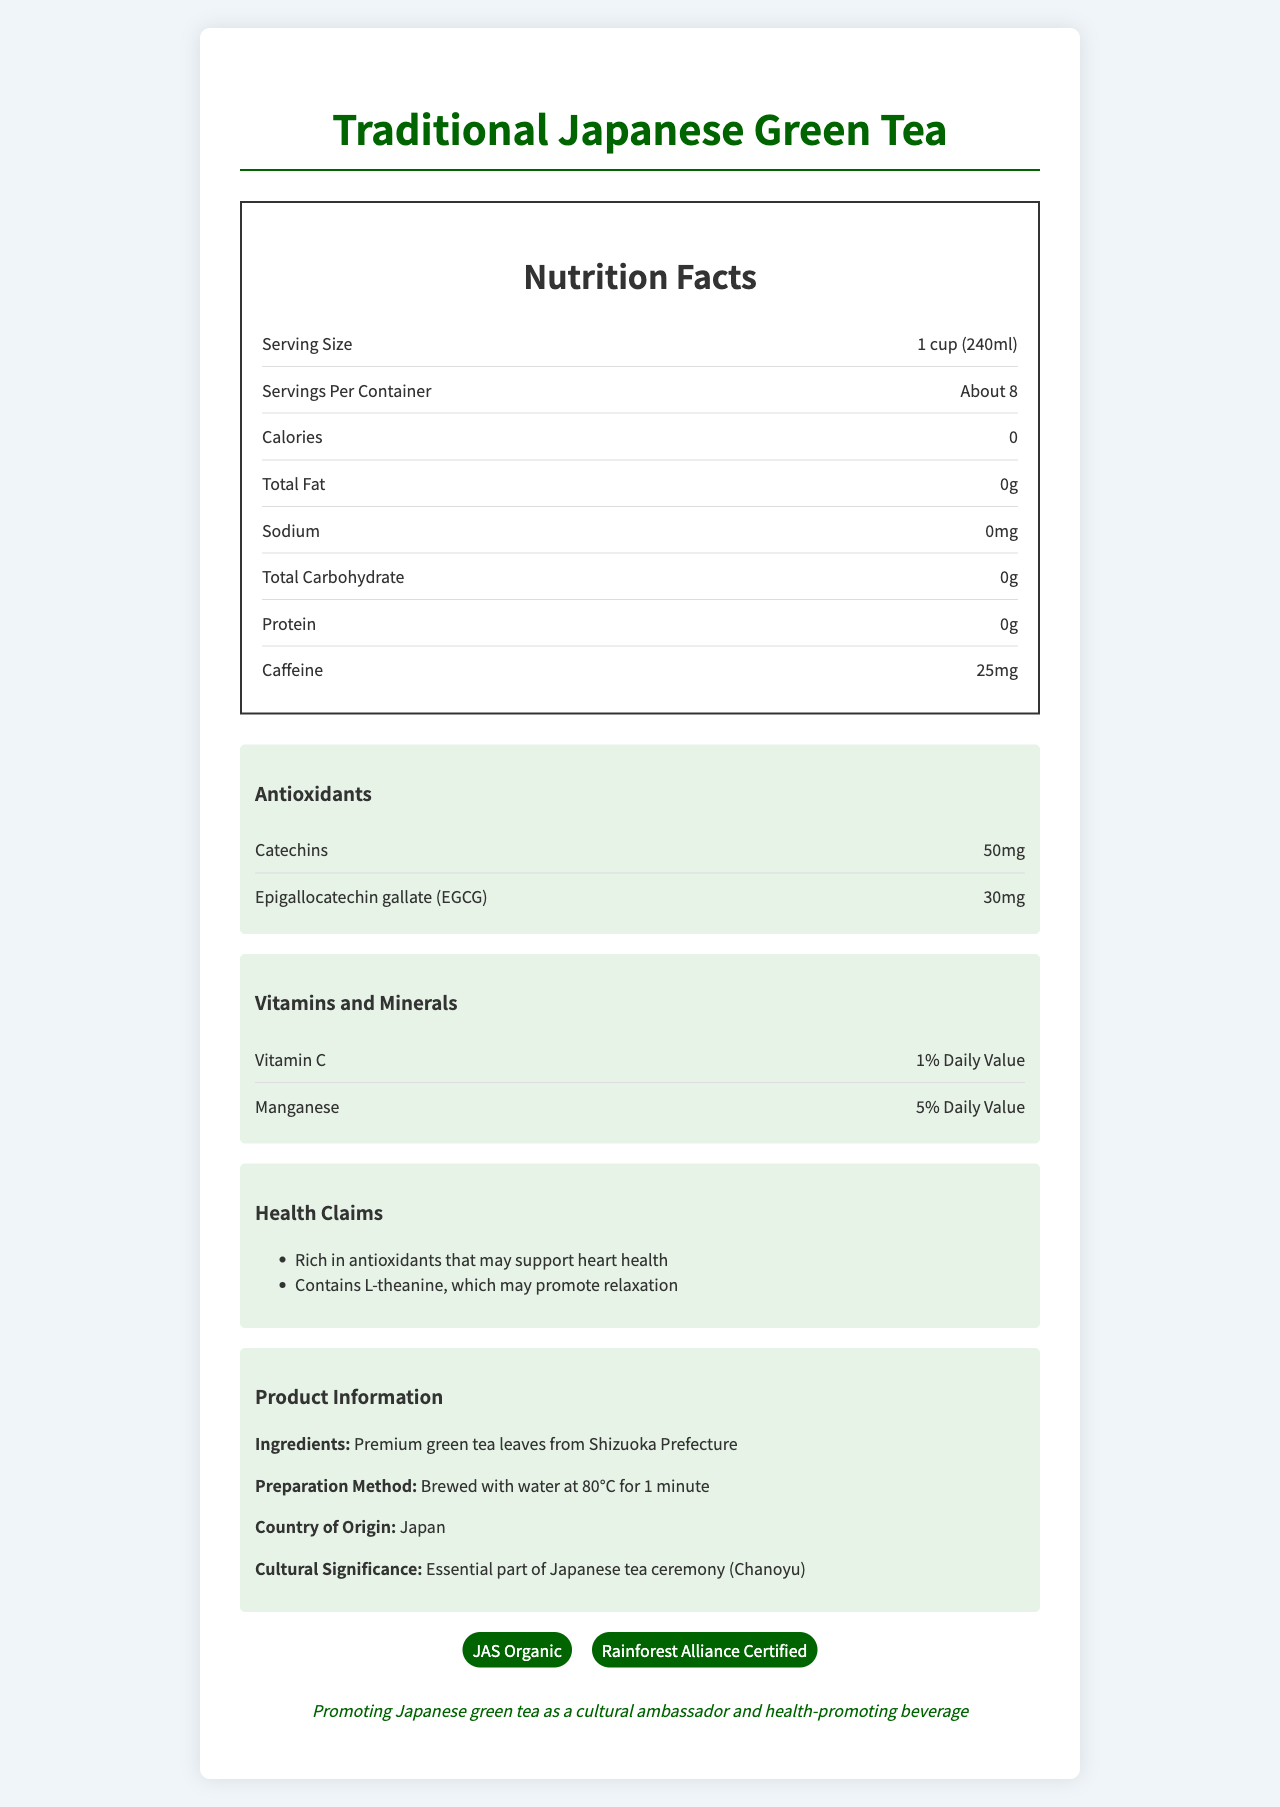how much caffeine is in one serving of the tea? The document specifies that one serving of the tea contains 25mg of caffeine.
Answer: 25mg what are the main antioxidants found in the traditional Japanese green tea? The nutrition facts highlight that the tea contains 50mg of catechins and 30mg of EGCG.
Answer: Catechins and Epigallocatechin gallate (EGCG) how many servings are there per container? Under the nutrition facts, it states that there are about 8 servings per container.
Answer: About 8 which type of certification does the product have? A. USDA Organic B. JAS Organic C. FDA Approved The document shows that the product is JAS Organic certified.
Answer: B what is the serving size for the traditional Japanese green tea? The serving size is given as 1 cup, which is equal to 240ml.
Answer: 1 cup (240ml) does the product contain any calories? The document lists the calorie content as 0.
Answer: No from which prefecture in Japan are the tea leaves sourced? The ingredients section mentions that the tea leaves are from Shizuoka Prefecture.
Answer: Shizuoka Prefecture what are the health claims made about this tea? The health claims highlighted in the document are about the tea being rich in antioxidants and L-theanine.
Answer: Rich in antioxidants that may support heart health; Contains L-theanine, which may promote relaxation what percentage of the daily value for Manganese does one serving of tea provide? The section on vitamins and minerals states that one serving provides 5% of the daily value for Manganese.
Answer: 5% Daily Value based on the document, what is the main export market for the traditional Japanese green tea? A. United States B. European Union C. China D. All of the above The export information lists the main export markets as the United States, European Union, and China.
Answer: D is this product suitable for a low-sodium diet? The sodium content is listed as 0mg, making it suitable for a low-sodium diet.
Answer: Yes summarize the main idea of the document. The document is a comprehensive overview of Traditional Japanese Green Tea, including its nutritional facts, health claims, cultural importance, and export information, aiming to present it as a healthy and culturally significant beverage.
Answer: The document provides detailed nutritional information about Traditional Japanese Green Tea, highlighting its zero-calorie content, presence of antioxidants like catechins and EGCG, 25mg of caffeine per serving, and various certifications like JAS Organic. It also emphasizes health benefits, cultural significance, and sustainability. what is the recommended brewing temperature and time for this green tea? The preparation method section suggests brewing the tea with water at 80°C for 1 minute.
Answer: Brewed with water at 80°C for 1 minute are there any vitamins in the tea? The tea contains Vitamin C, providing 1% of the daily value per serving.
Answer: Yes does the product promote relaxation? One of the health claims is that the tea contains L-theanine, which may promote relaxation.
Answer: Yes how many grams of protein does one serving of the tea contain? The nutrition facts section specifies that one serving contains 0g of protein.
Answer: 0g what are the main antioxidants found in the tea and their respective amounts? A. Catechins - 20mg, EGCG - 30mg B. Catechins - 50mg, EGCG - 30mg C. Catechins - 75mg, EGCG - 45mg The document lists 50mg of catechins and 30mg of EGCG as the main antioxidants found in the tea.
Answer: B how much Vitamin C does one serving provide in terms of daily value percentage? The document indicates that one serving provides 1% of the daily value of Vitamin C.
Answer: 1% Daily Value how many calories are in one container of the tea? The document provides calorie information per serving but does not specify the total calories per container.
Answer: Not enough information 